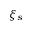Convert formula to latex. <formula><loc_0><loc_0><loc_500><loc_500>\xi _ { s }</formula> 